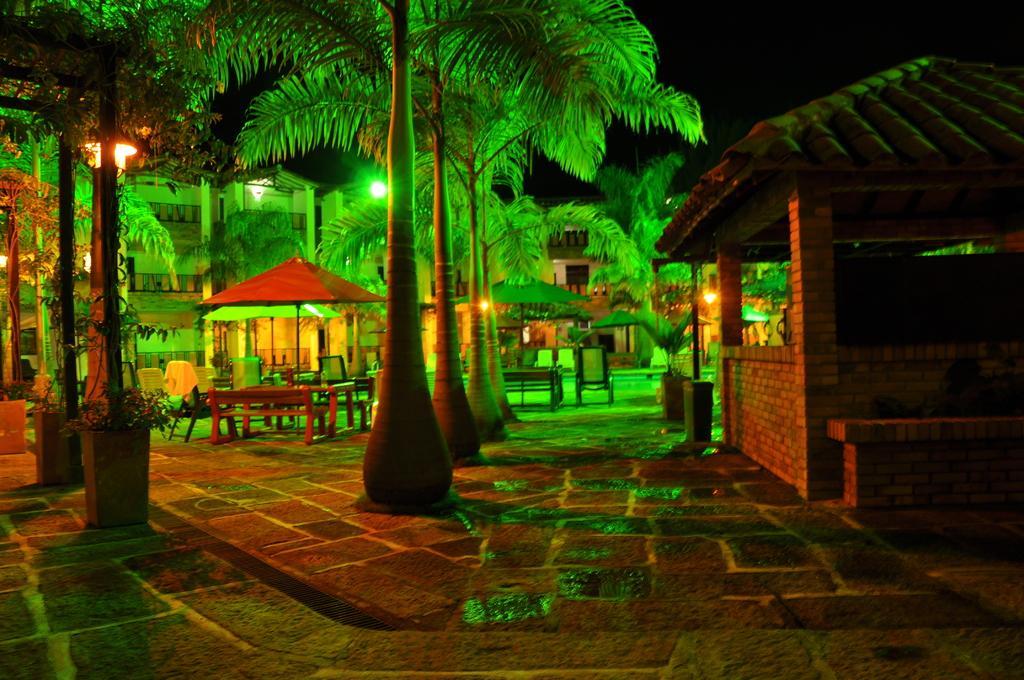Please provide a concise description of this image. In this image, we can see but, umbrellas, benches, chairs, trees, plants, path and lights. Background we can see building and dark view. 